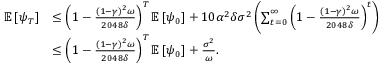Convert formula to latex. <formula><loc_0><loc_0><loc_500><loc_500>\begin{array} { r l } { \mathbb { E } \left [ \psi _ { T } \right ] } & { \leq \left ( 1 - \frac { ( 1 - \gamma ) ^ { 2 } \omega } { 2 0 4 8 \delta } \right ) ^ { T } \mathbb { E } \left [ \psi _ { 0 } \right ] + 1 0 \alpha ^ { 2 } \delta \sigma ^ { 2 } \left ( \sum _ { t = 0 } ^ { \infty } \left ( 1 - \frac { ( 1 - \gamma ) ^ { 2 } \omega } { 2 0 4 8 \delta } \right ) ^ { t } \right ) } \\ & { \leq \left ( 1 - \frac { ( 1 - \gamma ) ^ { 2 } \omega } { 2 0 4 8 \delta } \right ) ^ { T } \mathbb { E } \left [ \psi _ { 0 } \right ] + \frac { \sigma ^ { 2 } } { \omega } . } \end{array}</formula> 